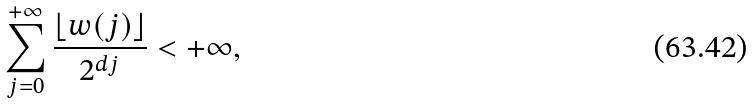<formula> <loc_0><loc_0><loc_500><loc_500>\sum _ { j = 0 } ^ { + \infty } \frac { \lfloor w ( j ) \rfloor } { 2 ^ { d j } } < + \infty ,</formula> 